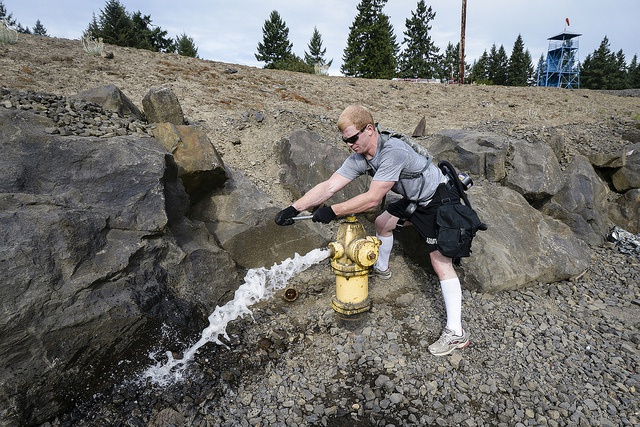Describe the objects in this image and their specific colors. I can see people in darkgray, black, lightgray, and gray tones, fire hydrant in darkgray, khaki, tan, gray, and olive tones, backpack in darkgray, black, and gray tones, and backpack in darkgray, gray, black, and lightgray tones in this image. 